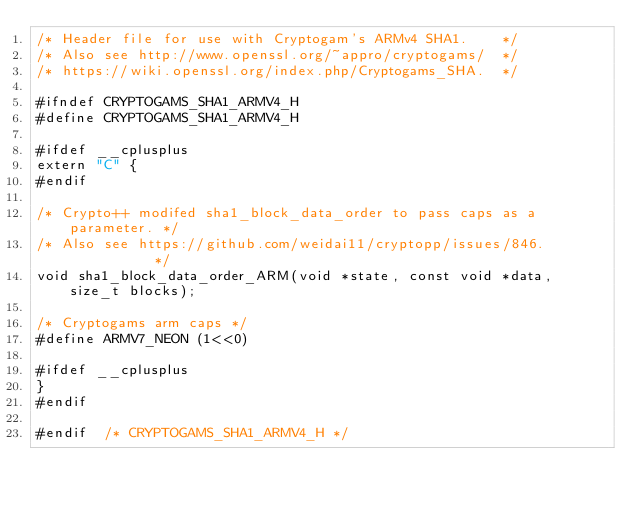Convert code to text. <code><loc_0><loc_0><loc_500><loc_500><_C_>/* Header file for use with Cryptogam's ARMv4 SHA1.    */
/* Also see http://www.openssl.org/~appro/cryptogams/  */
/* https://wiki.openssl.org/index.php/Cryptogams_SHA.  */

#ifndef CRYPTOGAMS_SHA1_ARMV4_H
#define CRYPTOGAMS_SHA1_ARMV4_H

#ifdef __cplusplus
extern "C" {
#endif

/* Crypto++ modifed sha1_block_data_order to pass caps as a parameter. */
/* Also see https://github.com/weidai11/cryptopp/issues/846.           */
void sha1_block_data_order_ARM(void *state, const void *data, size_t blocks);

/* Cryptogams arm caps */
#define ARMV7_NEON (1<<0)

#ifdef __cplusplus
}
#endif

#endif  /* CRYPTOGAMS_SHA1_ARMV4_H */
</code> 